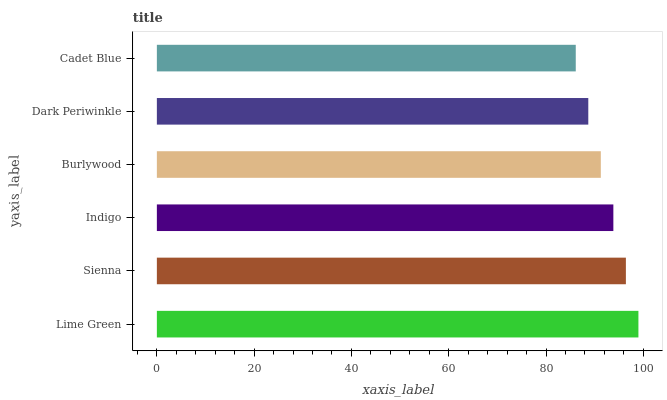Is Cadet Blue the minimum?
Answer yes or no. Yes. Is Lime Green the maximum?
Answer yes or no. Yes. Is Sienna the minimum?
Answer yes or no. No. Is Sienna the maximum?
Answer yes or no. No. Is Lime Green greater than Sienna?
Answer yes or no. Yes. Is Sienna less than Lime Green?
Answer yes or no. Yes. Is Sienna greater than Lime Green?
Answer yes or no. No. Is Lime Green less than Sienna?
Answer yes or no. No. Is Indigo the high median?
Answer yes or no. Yes. Is Burlywood the low median?
Answer yes or no. Yes. Is Burlywood the high median?
Answer yes or no. No. Is Dark Periwinkle the low median?
Answer yes or no. No. 